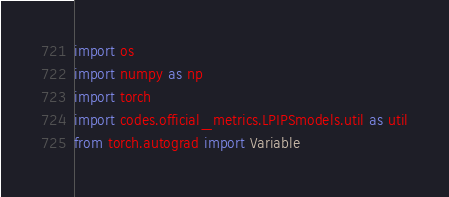<code> <loc_0><loc_0><loc_500><loc_500><_Python_>import os
import numpy as np
import torch
import codes.official_metrics.LPIPSmodels.util as util
from torch.autograd import Variable</code> 